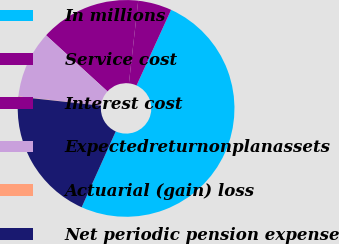Convert chart. <chart><loc_0><loc_0><loc_500><loc_500><pie_chart><fcel>In millions<fcel>Service cost<fcel>Interest cost<fcel>Expectedreturnonplanassets<fcel>Actuarial (gain) loss<fcel>Net periodic pension expense<nl><fcel>49.9%<fcel>5.03%<fcel>15.0%<fcel>10.02%<fcel>0.05%<fcel>19.99%<nl></chart> 